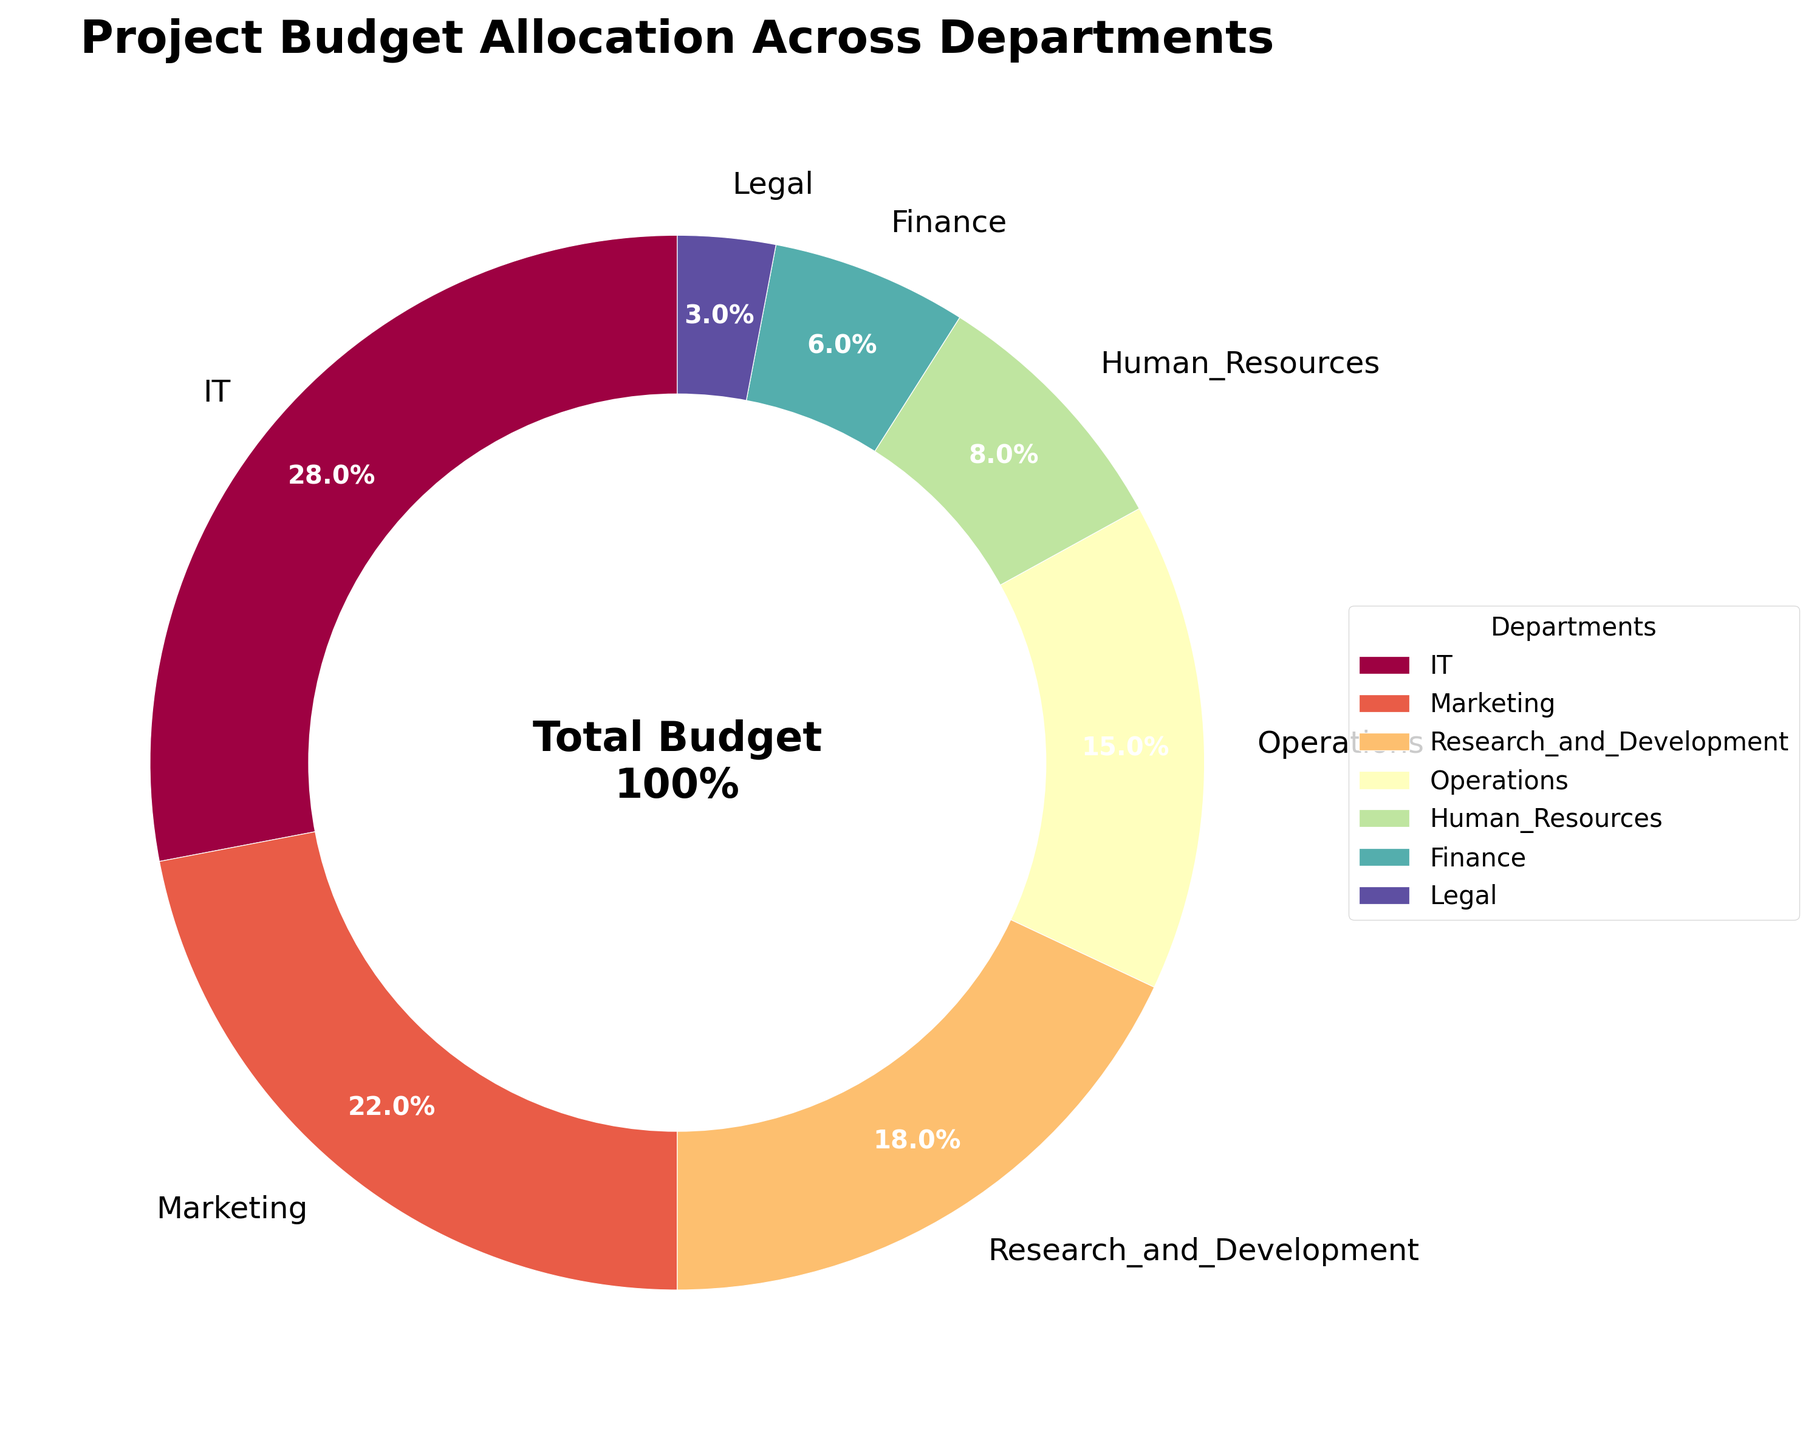What percentage of the budget is allocated to Marketing and IT combined? To find the combined budget allocation for Marketing and IT, add their individual percentages (22% + 28%).
Answer: 50% Which department receives the smallest portion of the budget? Check the department with the smallest numerical value in the pie chart, which is Legal with 3%.
Answer: Legal How does the budget allocation for Human Resources compare to that for Finance? Compare the values directly from the chart: Human Resources has 8%, and Finance has 6%. Since 8% is greater than 6%, Human Resources receives a higher allocation.
Answer: Human Resources > Finance What is the difference in budget allocation between Research and Development and Operations? Subtract the budget allocation of Operations (15%) from Research and Development (18%) to get the difference. 18% - 15% = 3%.
Answer: 3% If the total budget is $1,000,000, how much is allocated to Legal? Calculate 3% of $1,000,000: (3/100) * 1,000,000 = $30,000.
Answer: $30,000 Which two departments combined account for a third of the total budget? A third of the budget is approximately 33.3%. Adding Marketing (22%) and Operations (15%) gives 37%, which is slightly over a third. Checking the next possible combination, IT (28%) and Legal (3%) gives 31%, which is close to a third. However, IT and Marketing combined are more accurate for this purpose.
Answer: IT and Marketing Compare the budget allocation for Human Resources with Operations. Is Human Resources allocated more than half of what Operations gets? Compare the values: Human Resources (8%) and Operations (15%). Calculate if 8% is more than half of 15%, which is 7.5%. Since 8% is greater than 7.5%, the answer is yes.
Answer: Yes Are there any departments that receive less than 10% of the budget? If so, which ones? Check the chart for departments with values less than 10%. Human Resources (8%), Finance (6%), and Legal (3%) all receive less than 10%.
Answer: Human Resources, Finance, Legal How much more budget is allocated to IT compared to Research and Development? Subtract the budget allocation of Research and Development (18%) from IT (28%) to get the difference. 28% - 18% = 10%.
Answer: 10% The sum of the budgets for which three departments is closest to 40% of the total budget? Adding three departments to get close to 40%. IT (28%) + Finance (6%) + Legal (3%) = 37%, which is close but not accurate. Marketing (22%) + R&D (18%) = 40%, which sums exactly to 40%. Thus, Marketing and R&D sum closest to 40%.
Answer: Marketing and R&D 